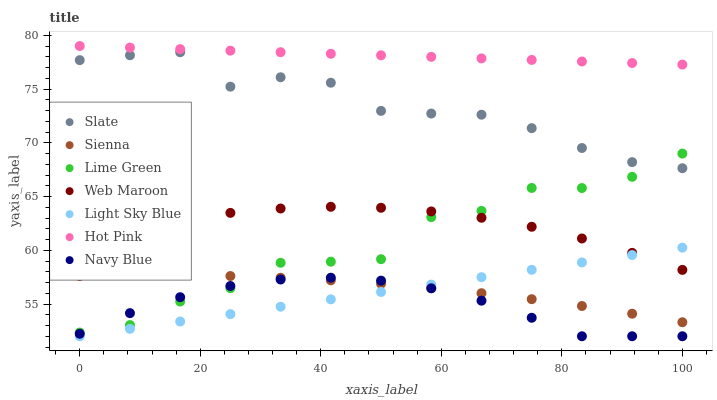Does Navy Blue have the minimum area under the curve?
Answer yes or no. Yes. Does Hot Pink have the maximum area under the curve?
Answer yes or no. Yes. Does Slate have the minimum area under the curve?
Answer yes or no. No. Does Slate have the maximum area under the curve?
Answer yes or no. No. Is Light Sky Blue the smoothest?
Answer yes or no. Yes. Is Lime Green the roughest?
Answer yes or no. Yes. Is Slate the smoothest?
Answer yes or no. No. Is Slate the roughest?
Answer yes or no. No. Does Navy Blue have the lowest value?
Answer yes or no. Yes. Does Slate have the lowest value?
Answer yes or no. No. Does Hot Pink have the highest value?
Answer yes or no. Yes. Does Slate have the highest value?
Answer yes or no. No. Is Web Maroon less than Hot Pink?
Answer yes or no. Yes. Is Hot Pink greater than Web Maroon?
Answer yes or no. Yes. Does Lime Green intersect Navy Blue?
Answer yes or no. Yes. Is Lime Green less than Navy Blue?
Answer yes or no. No. Is Lime Green greater than Navy Blue?
Answer yes or no. No. Does Web Maroon intersect Hot Pink?
Answer yes or no. No. 